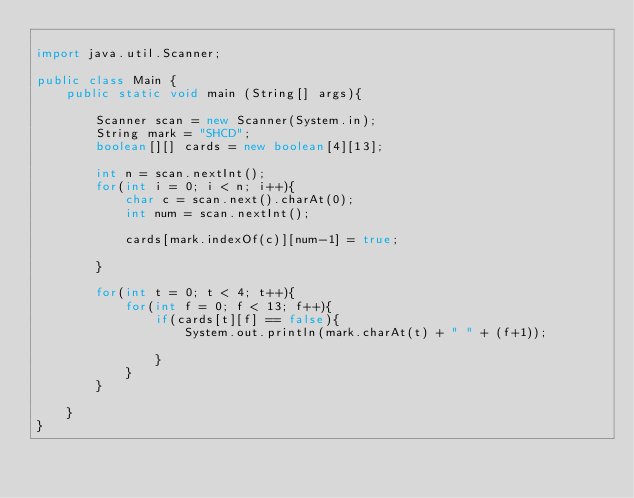Convert code to text. <code><loc_0><loc_0><loc_500><loc_500><_Java_>
import java.util.Scanner;

public class Main {
    public static void main (String[] args){

        Scanner scan = new Scanner(System.in);
        String mark = "SHCD";
        boolean[][] cards = new boolean[4][13];

        int n = scan.nextInt();
        for(int i = 0; i < n; i++){
            char c = scan.next().charAt(0);
            int num = scan.nextInt();

            cards[mark.indexOf(c)][num-1] = true;
 
        }

        for(int t = 0; t < 4; t++){
            for(int f = 0; f < 13; f++){
                if(cards[t][f] == false){
                    System.out.println(mark.charAt(t) + " " + (f+1));

                }
            }
        }

    }
}

</code> 